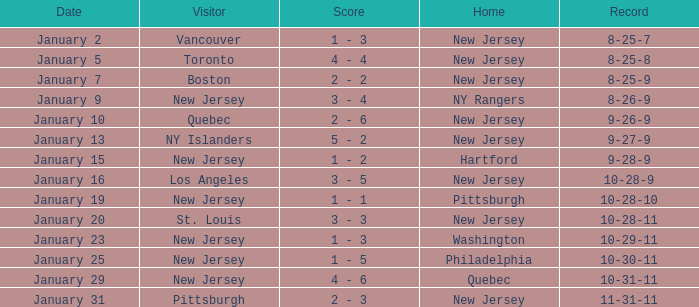What was the date that concluded with a record of 8-25-7? January 2. 